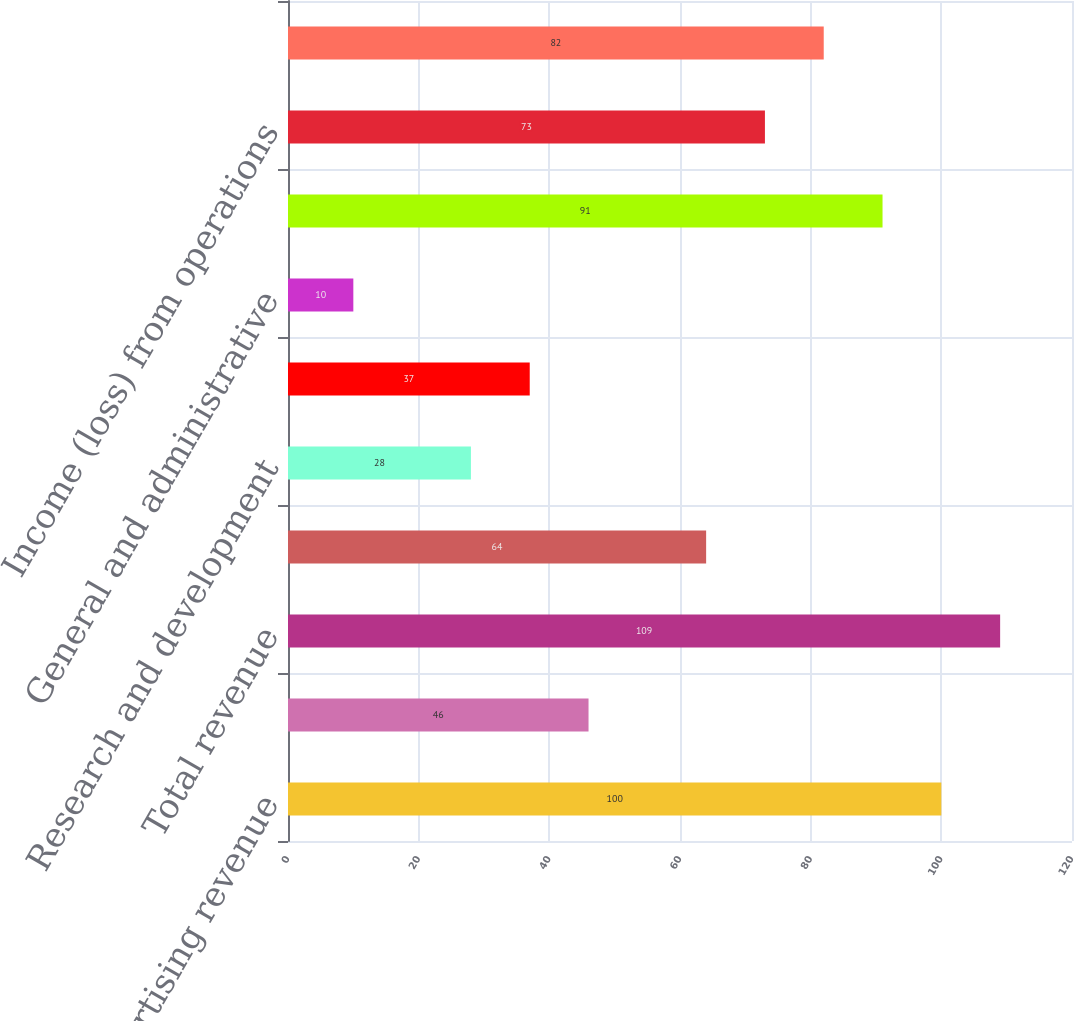Convert chart to OTSL. <chart><loc_0><loc_0><loc_500><loc_500><bar_chart><fcel>Advertising revenue<fcel>Payments and other fees<fcel>Total revenue<fcel>Cost of revenue<fcel>Research and development<fcel>Marketing and sales<fcel>General and administrative<fcel>Total costs and expenses<fcel>Income (loss) from operations<fcel>Income (loss) before<nl><fcel>100<fcel>46<fcel>109<fcel>64<fcel>28<fcel>37<fcel>10<fcel>91<fcel>73<fcel>82<nl></chart> 